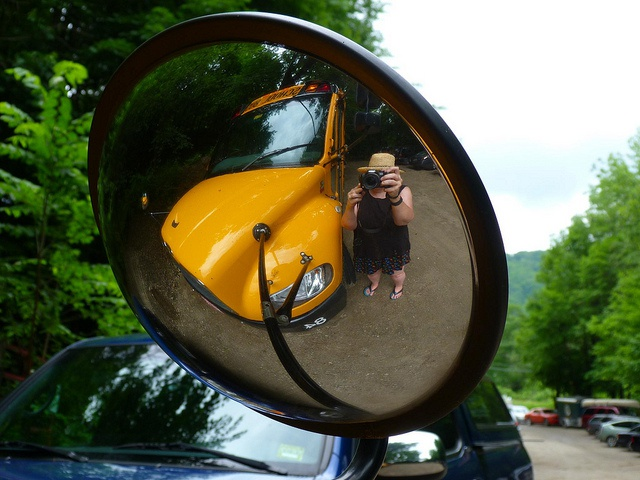Describe the objects in this image and their specific colors. I can see car in black, lightblue, and blue tones, truck in black, orange, olive, and maroon tones, people in black, gray, and maroon tones, car in black, gray, and darkgray tones, and car in black, maroon, brown, and gray tones in this image. 